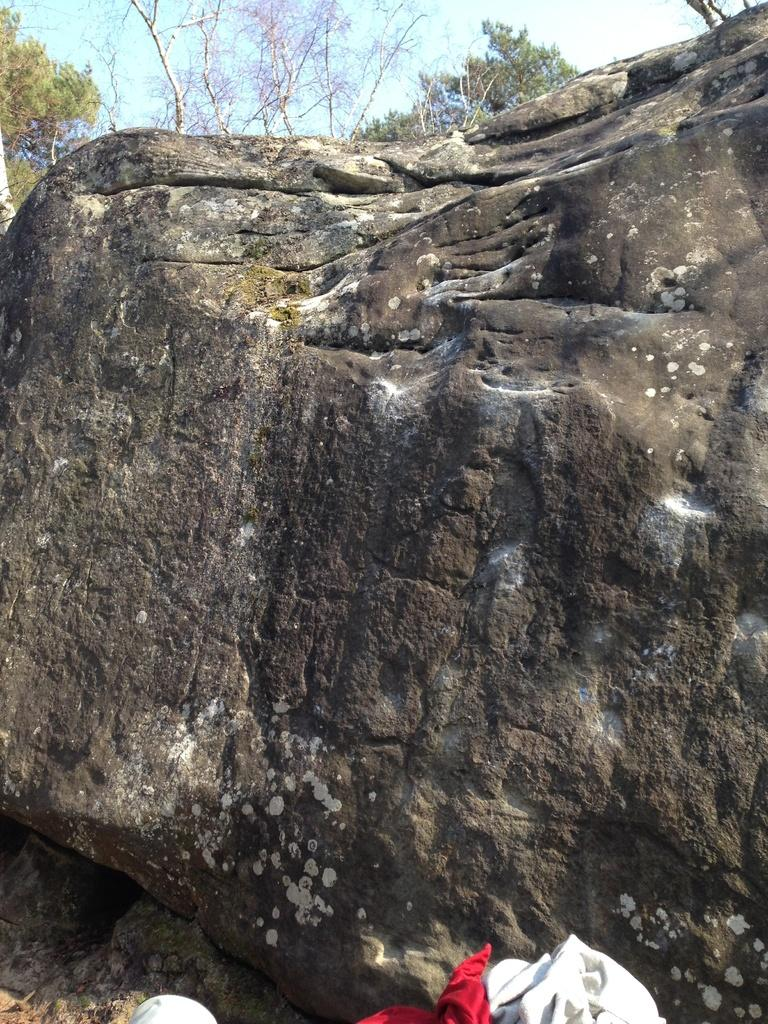What is the main object in the image? There is a rock in the image. What other natural elements can be seen in the image? There are trees and sky visible in the image. What is located in front of the rock? There are clothes in front of the rock. Is there a bridge visible in the image? No, there is no bridge present in the image. Can you see a rake being used in the image? No, there is no rake visible in the image. 